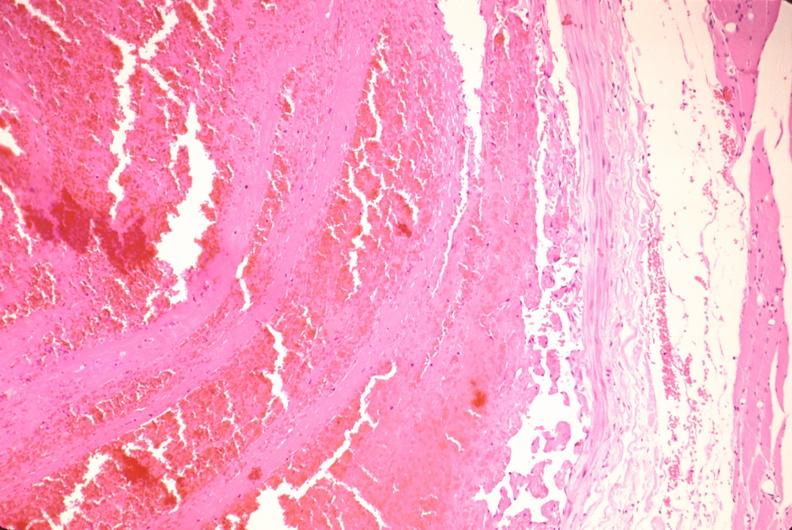what is present?
Answer the question using a single word or phrase. Cardiovascular 